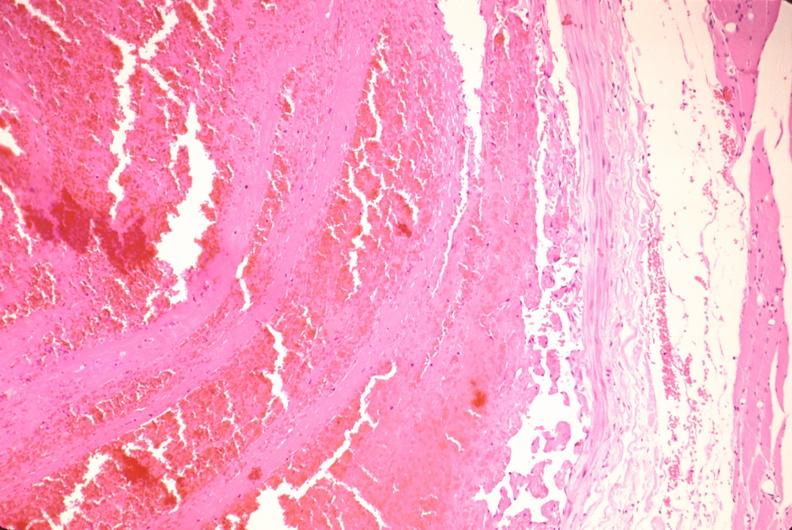what is present?
Answer the question using a single word or phrase. Cardiovascular 